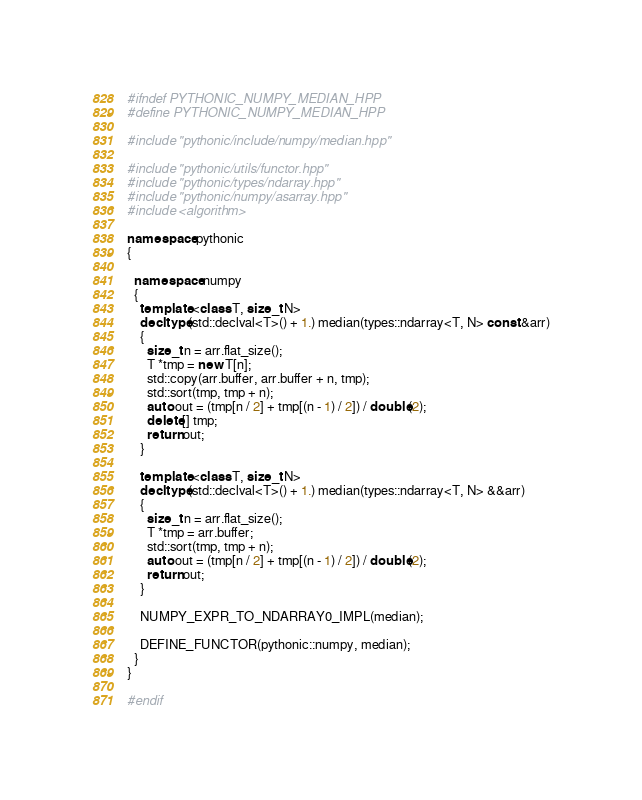<code> <loc_0><loc_0><loc_500><loc_500><_C++_>#ifndef PYTHONIC_NUMPY_MEDIAN_HPP
#define PYTHONIC_NUMPY_MEDIAN_HPP

#include "pythonic/include/numpy/median.hpp"

#include "pythonic/utils/functor.hpp"
#include "pythonic/types/ndarray.hpp"
#include "pythonic/numpy/asarray.hpp"
#include <algorithm>

namespace pythonic
{

  namespace numpy
  {
    template <class T, size_t N>
    decltype(std::declval<T>() + 1.) median(types::ndarray<T, N> const &arr)
    {
      size_t n = arr.flat_size();
      T *tmp = new T[n];
      std::copy(arr.buffer, arr.buffer + n, tmp);
      std::sort(tmp, tmp + n);
      auto out = (tmp[n / 2] + tmp[(n - 1) / 2]) / double(2);
      delete[] tmp;
      return out;
    }

    template <class T, size_t N>
    decltype(std::declval<T>() + 1.) median(types::ndarray<T, N> &&arr)
    {
      size_t n = arr.flat_size();
      T *tmp = arr.buffer;
      std::sort(tmp, tmp + n);
      auto out = (tmp[n / 2] + tmp[(n - 1) / 2]) / double(2);
      return out;
    }

    NUMPY_EXPR_TO_NDARRAY0_IMPL(median);

    DEFINE_FUNCTOR(pythonic::numpy, median);
  }
}

#endif
</code> 